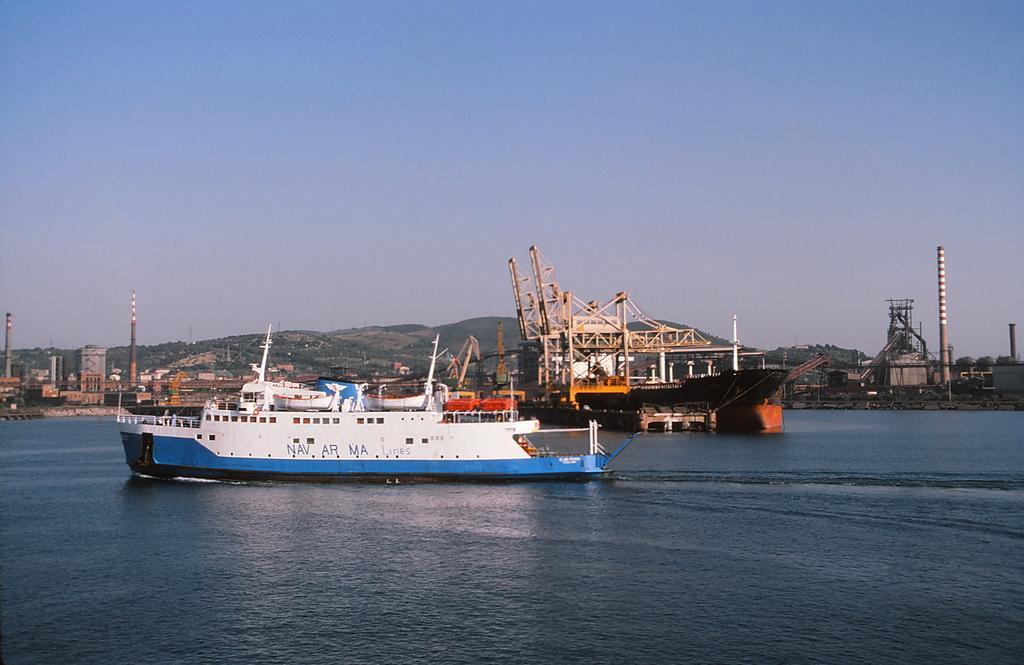In one or two sentences, can you explain what this image depicts? This image is taken outdoors. At the top of the image there is a sky. At the bottom of the image there is a river with water and there are many ships on the river and there are a huge machinery and a few poles. There are a few hills. 